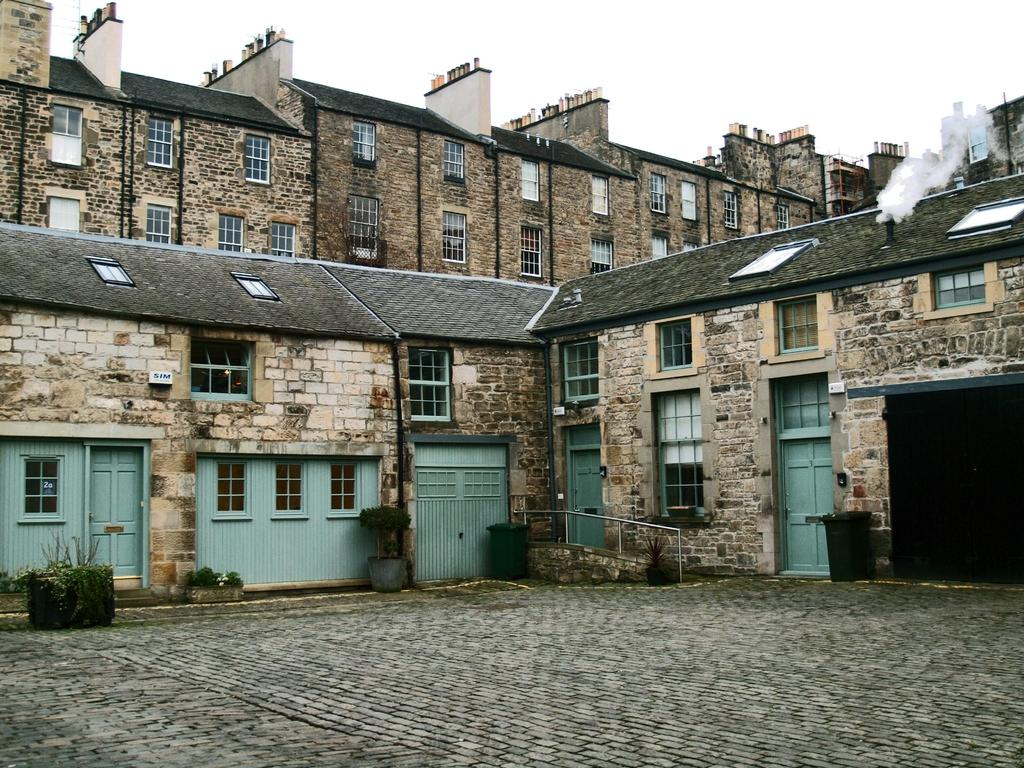What type of plants can be seen on the ground in the image? There are houseplants on the ground in the image. What other objects are on the ground in the image? There are dustbins on the ground in the image. What can be seen in the background of the image? Buildings and the sky are visible in the background of the image. What type of cheese is being offered by the buildings in the image? There is no cheese present in the image, nor is there any indication that the buildings are offering anything. 